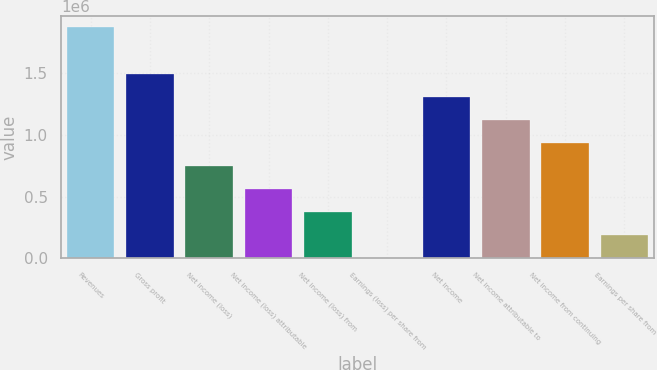Convert chart. <chart><loc_0><loc_0><loc_500><loc_500><bar_chart><fcel>Revenues<fcel>Gross profit<fcel>Net income (loss)<fcel>Net income (loss) attributable<fcel>Net income (loss) from<fcel>Earnings (loss) per share from<fcel>Net income<fcel>Net income attributable to<fcel>Net income from continuing<fcel>Earnings per share from<nl><fcel>1.87234e+06<fcel>1.49787e+06<fcel>748936<fcel>561702<fcel>374468<fcel>0.15<fcel>1.31064e+06<fcel>1.1234e+06<fcel>936170<fcel>187234<nl></chart> 